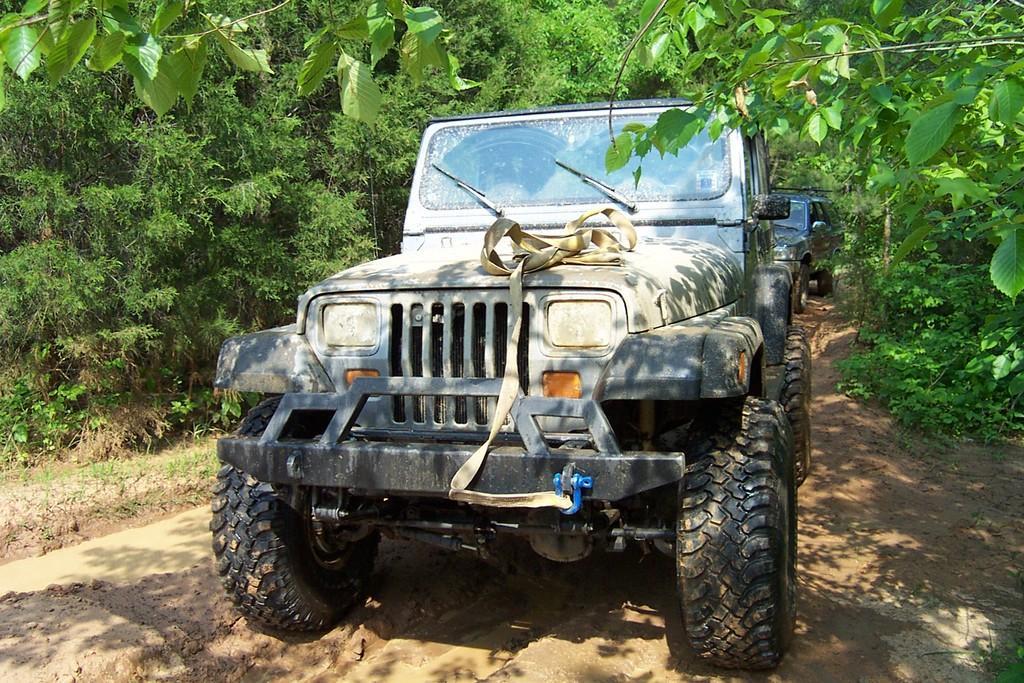In one or two sentences, can you explain what this image depicts? In this picture we can see vehicles, mud, trees and grass. 